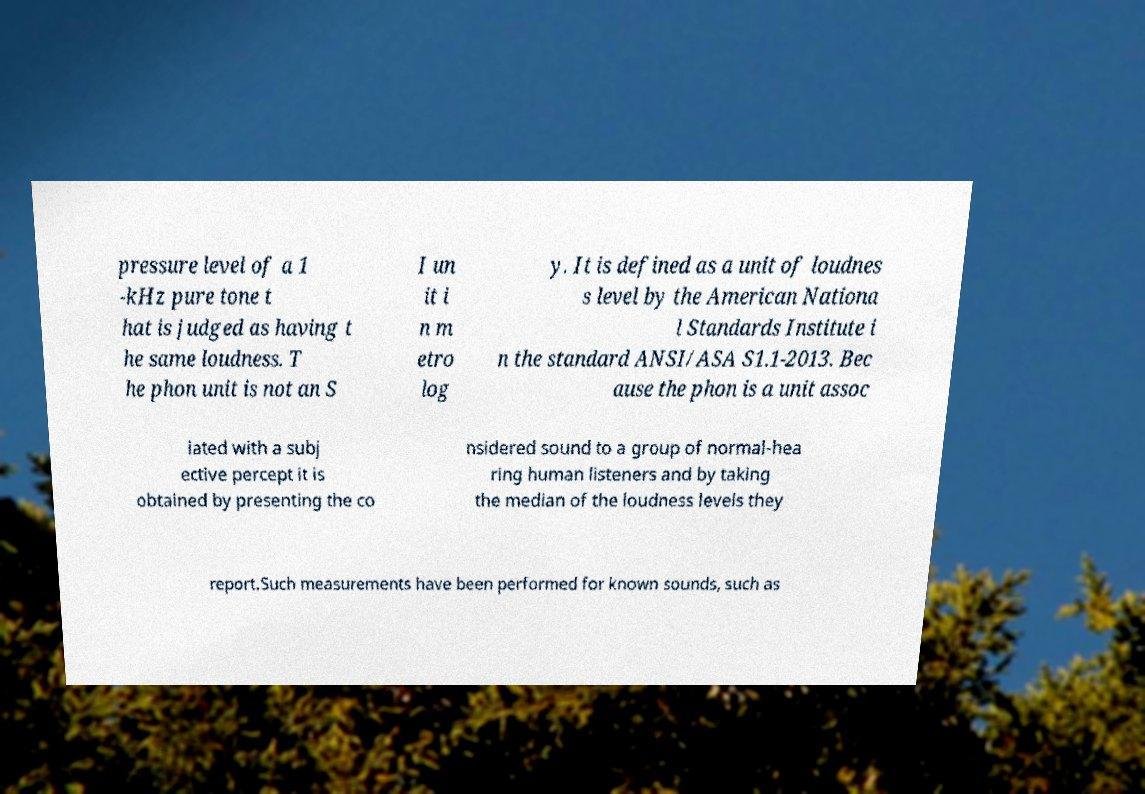Please identify and transcribe the text found in this image. pressure level of a 1 -kHz pure tone t hat is judged as having t he same loudness. T he phon unit is not an S I un it i n m etro log y. It is defined as a unit of loudnes s level by the American Nationa l Standards Institute i n the standard ANSI/ASA S1.1-2013. Bec ause the phon is a unit assoc iated with a subj ective percept it is obtained by presenting the co nsidered sound to a group of normal-hea ring human listeners and by taking the median of the loudness levels they report.Such measurements have been performed for known sounds, such as 